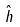<formula> <loc_0><loc_0><loc_500><loc_500>\hat { h }</formula> 